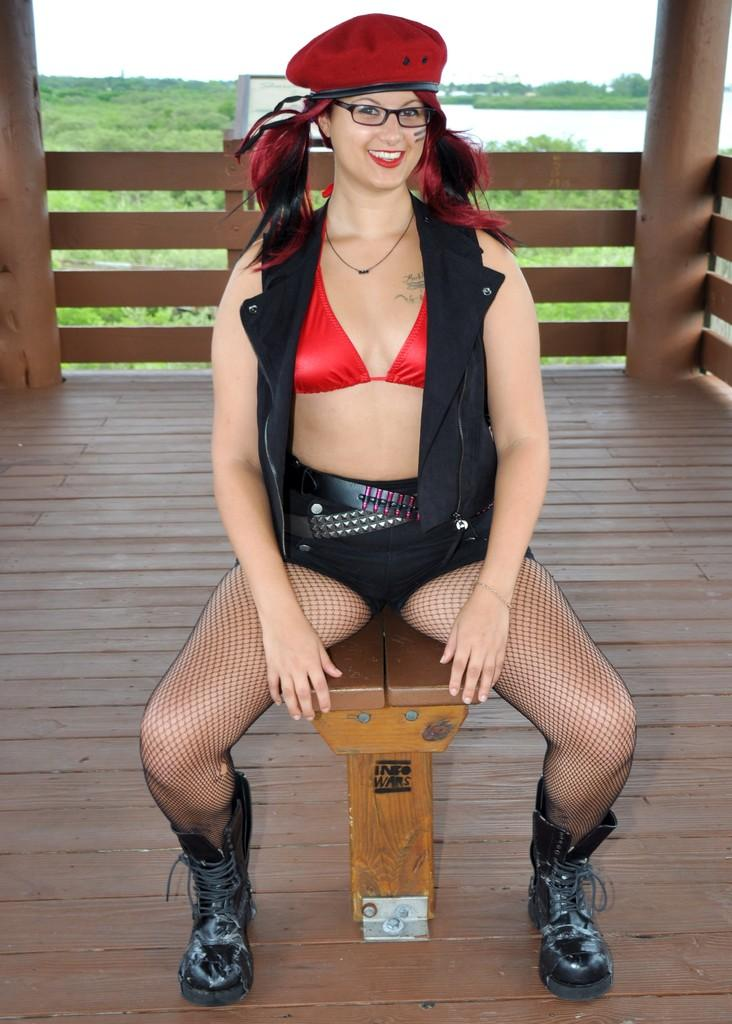Who is the main subject in the image? There is a woman in the image. What is the woman sitting on? The woman is sitting on a wooden stool. What type of barrier surrounds the woman? There is a wooden fence around the woman. What can be seen in the background of the image? There is a beautiful scenery in the background of the image. What type of cream can be seen on the woman's hands in the image? There is no cream visible on the woman's hands in the image. How many pins are holding the woman's dress in the image? The woman's dress is not being held by any pins in the image. 